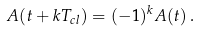Convert formula to latex. <formula><loc_0><loc_0><loc_500><loc_500>A ( t + k T _ { c l } ) = ( - 1 ) ^ { k } A ( t ) \, .</formula> 